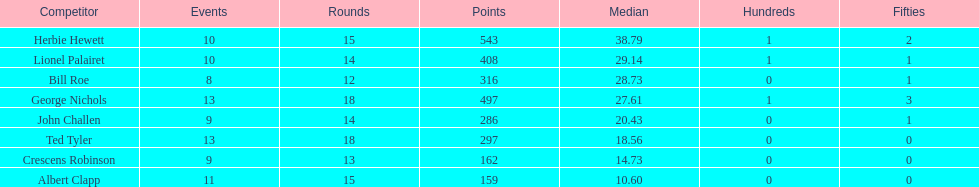How many runs did ted tyler have? 297. 